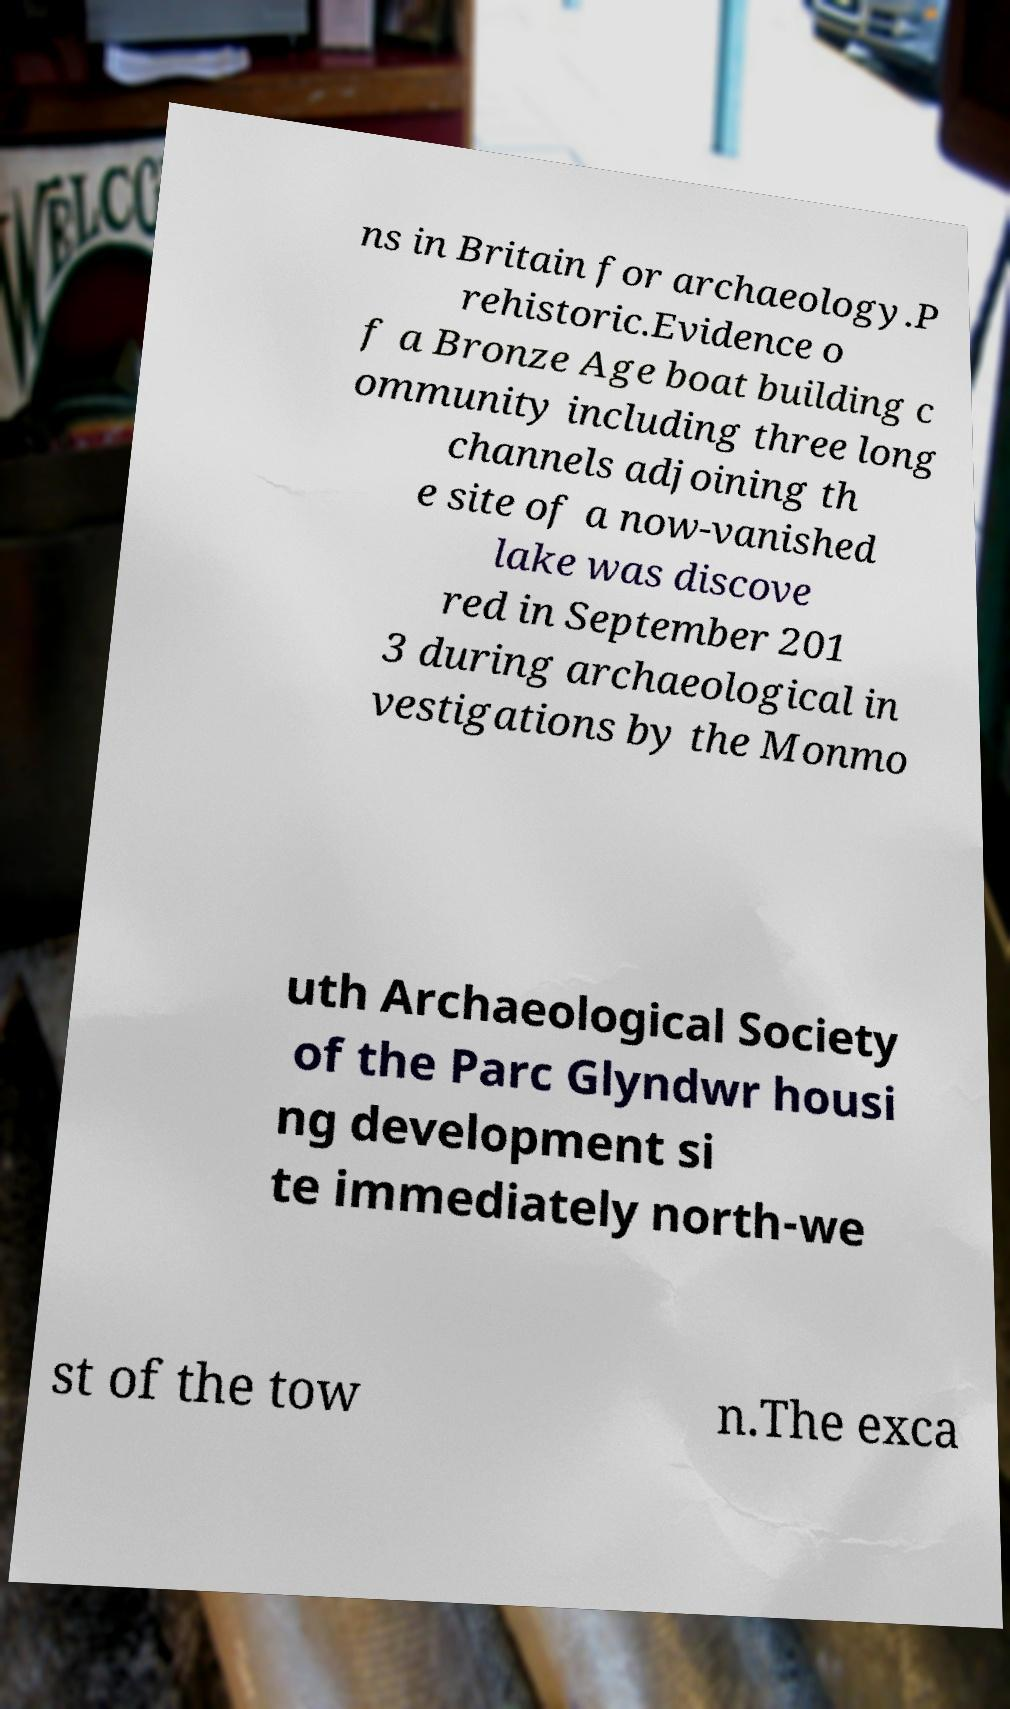Could you assist in decoding the text presented in this image and type it out clearly? ns in Britain for archaeology.P rehistoric.Evidence o f a Bronze Age boat building c ommunity including three long channels adjoining th e site of a now-vanished lake was discove red in September 201 3 during archaeological in vestigations by the Monmo uth Archaeological Society of the Parc Glyndwr housi ng development si te immediately north-we st of the tow n.The exca 